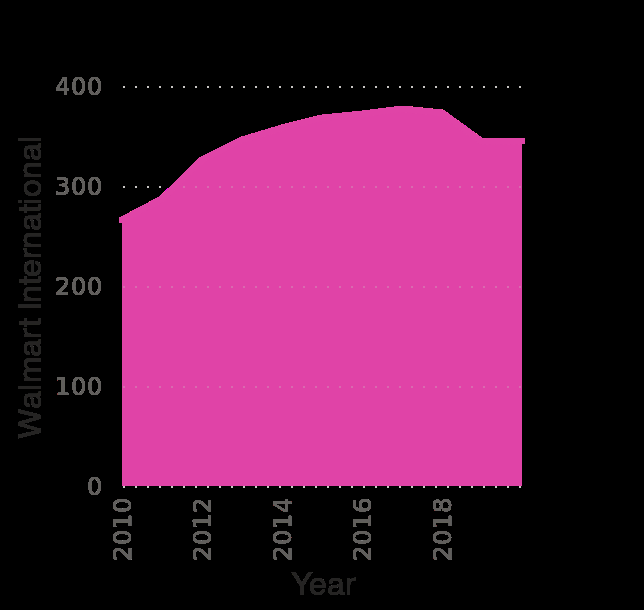<image>
What does the y-axis represent in the area plot? The y-axis represents Walmart International. 